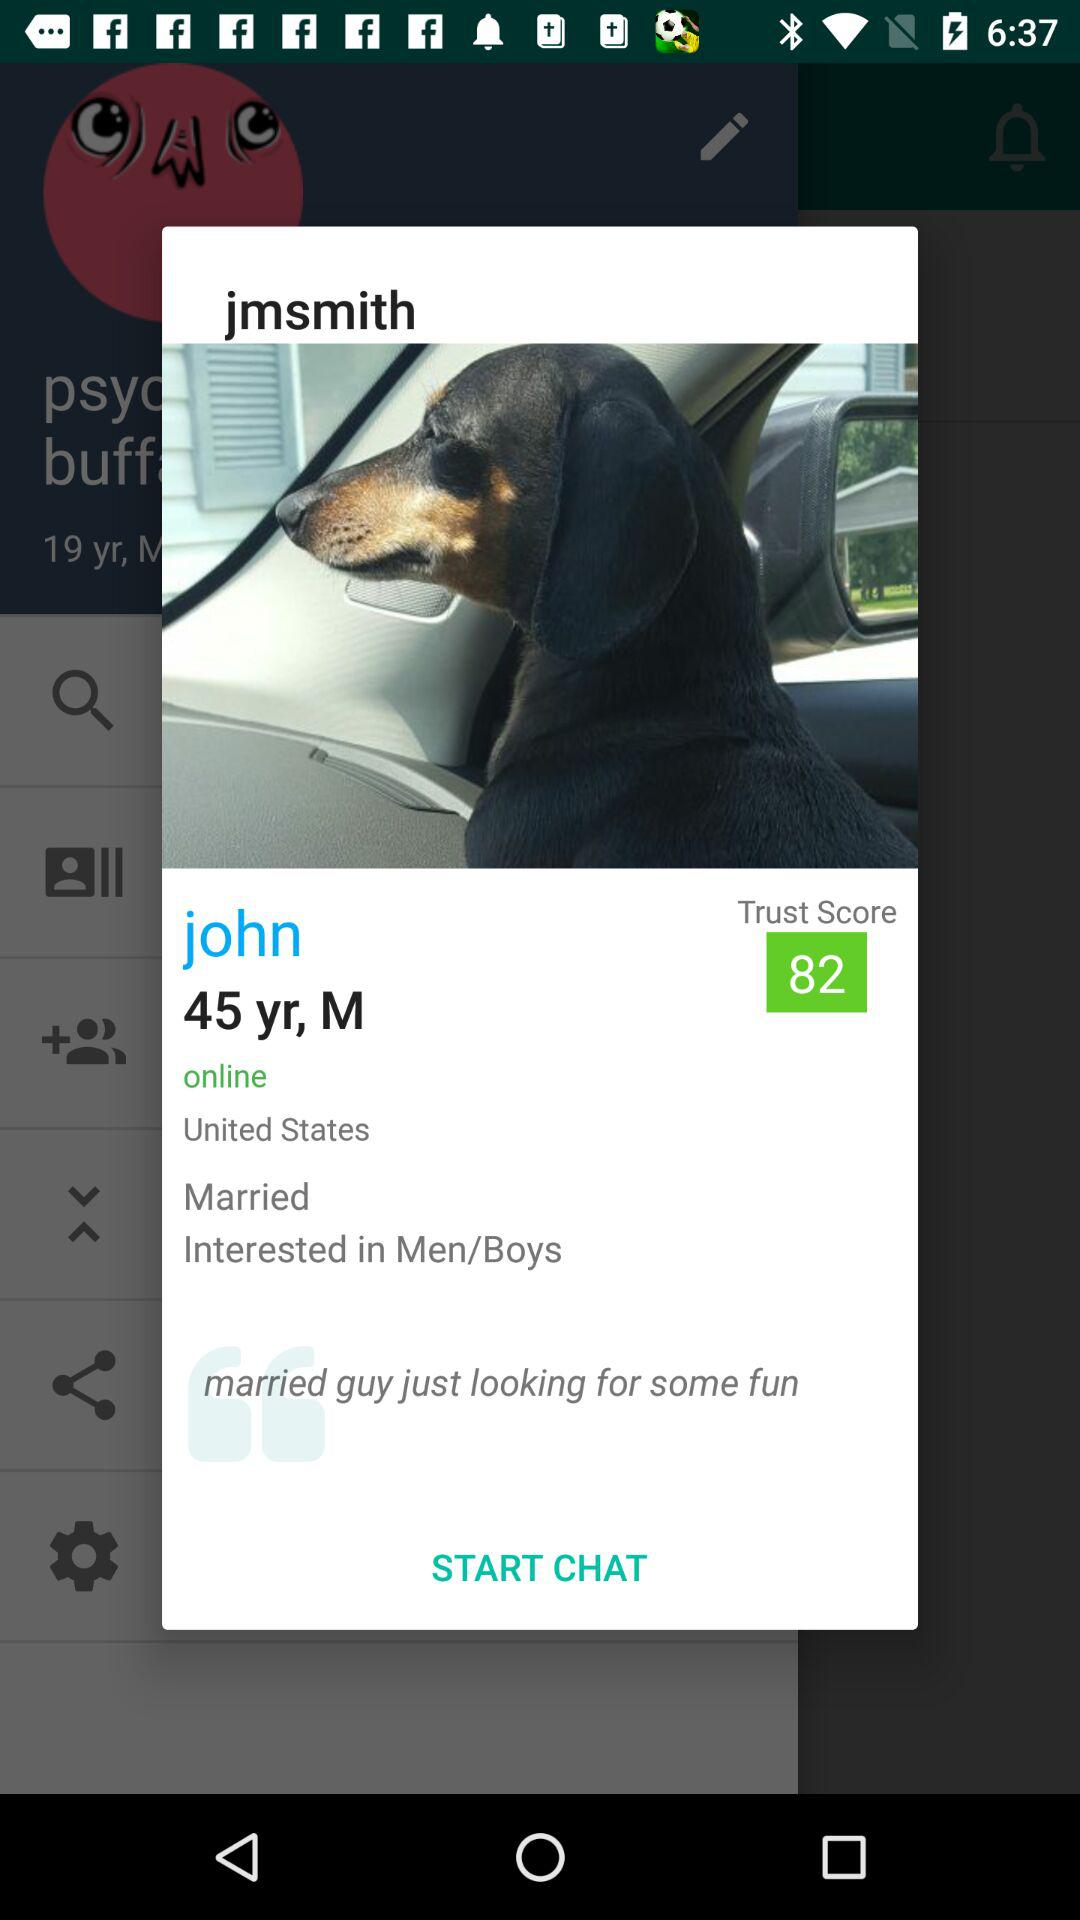What is the user name? The user name is "john". 